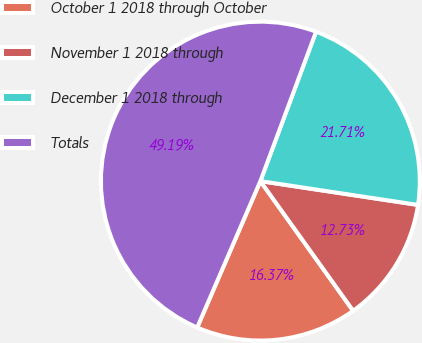Convert chart to OTSL. <chart><loc_0><loc_0><loc_500><loc_500><pie_chart><fcel>October 1 2018 through October<fcel>November 1 2018 through<fcel>December 1 2018 through<fcel>Totals<nl><fcel>16.37%<fcel>12.73%<fcel>21.71%<fcel>49.19%<nl></chart> 